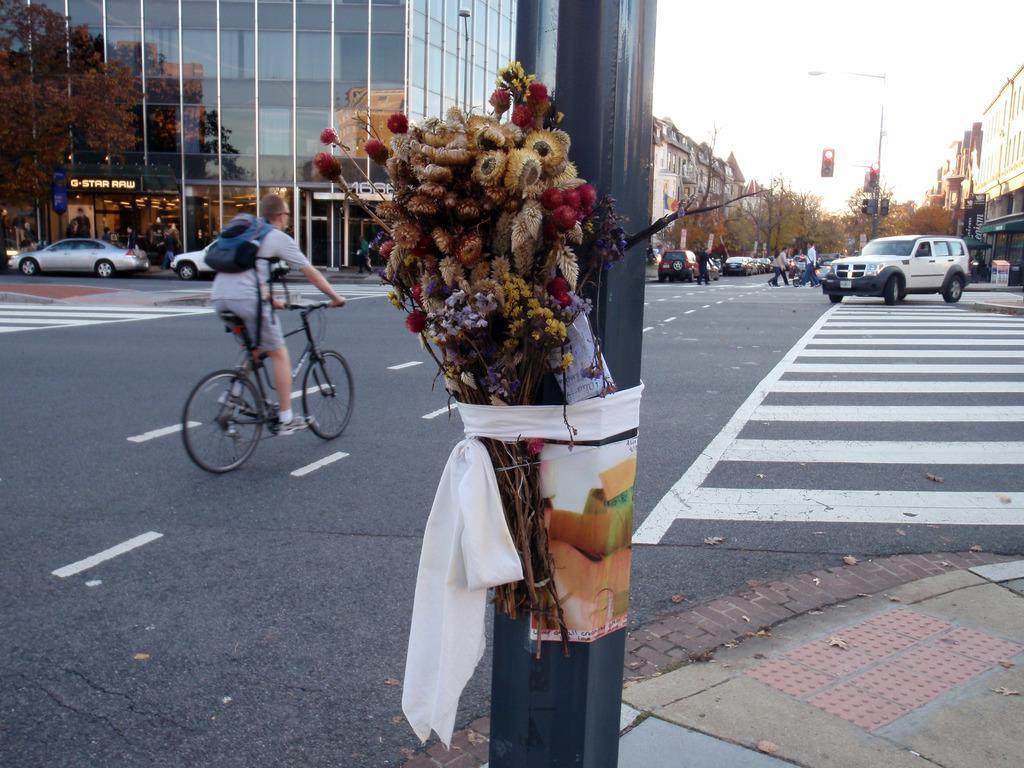Can you describe this image briefly? In this image we can see a pole. On the pole there are flowers tied. There are many vehicles on the road. There is a person wearing bag. He is riding a cycle. In the back there are buildings. Also there are trees. And we can see a traffic signal with pole. In the background there is sky. And we can see few people in the background. 